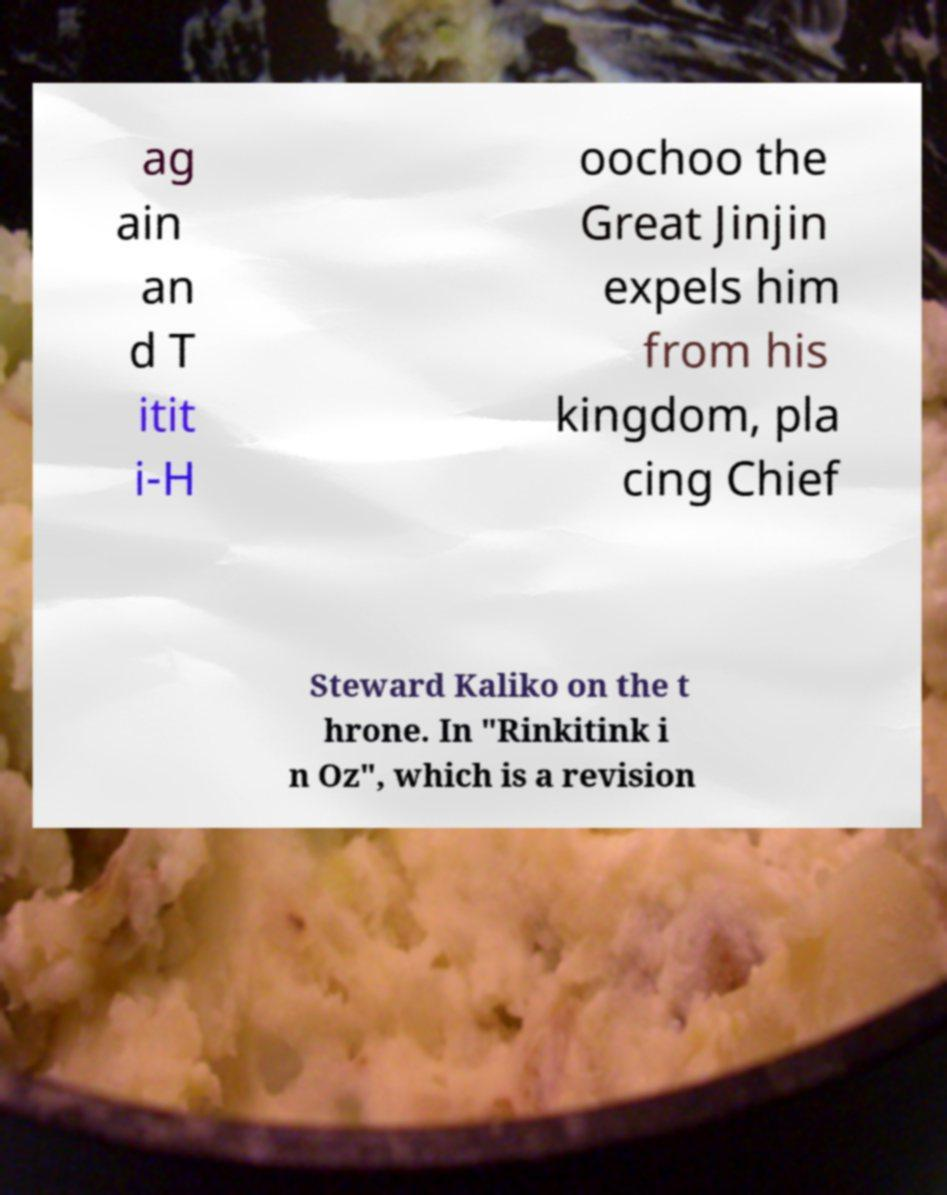Please read and relay the text visible in this image. What does it say? ag ain an d T itit i-H oochoo the Great Jinjin expels him from his kingdom, pla cing Chief Steward Kaliko on the t hrone. In "Rinkitink i n Oz", which is a revision 